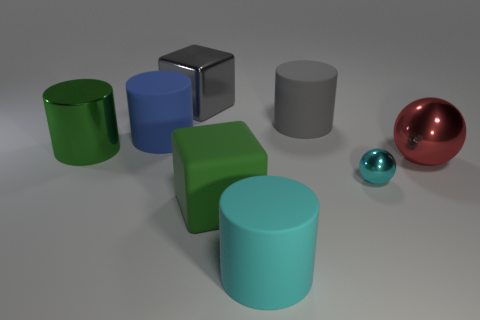How many objects are tiny cyan spheres or rubber spheres?
Keep it short and to the point. 1. Does the cyan rubber thing have the same size as the gray thing that is to the right of the big green block?
Offer a very short reply. Yes. There is a green object that is in front of the big green thing behind the big green object that is in front of the large red metal object; what size is it?
Make the answer very short. Large. Is there a yellow matte cylinder?
Give a very brief answer. No. What material is the cylinder that is the same color as the large metal cube?
Your answer should be very brief. Rubber. What number of rubber objects have the same color as the tiny sphere?
Make the answer very short. 1. How many objects are either small cyan things to the right of the green metal cylinder or big metal things that are behind the big gray rubber cylinder?
Offer a very short reply. 2. There is a big cylinder in front of the red thing; how many red objects are left of it?
Offer a terse response. 0. There is a big cylinder that is made of the same material as the small sphere; what is its color?
Offer a very short reply. Green. Are there any metal cylinders that have the same size as the gray metal block?
Provide a short and direct response. Yes. 